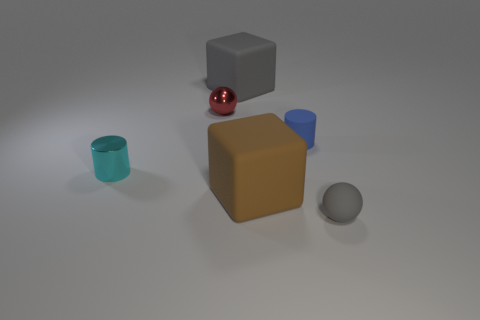How many objects are the same color as the tiny rubber sphere?
Give a very brief answer. 1. There is a tiny ball that is on the left side of the big gray matte object; are there any small metallic things that are on the left side of it?
Provide a short and direct response. Yes. How many other things are there of the same shape as the big gray object?
Your answer should be very brief. 1. There is a gray rubber object that is behind the red shiny ball; is its shape the same as the thing that is on the right side of the small blue object?
Provide a succinct answer. No. There is a small sphere on the left side of the small rubber object in front of the brown block; how many large rubber blocks are to the left of it?
Keep it short and to the point. 0. The tiny shiny sphere has what color?
Your answer should be very brief. Red. How many other objects are there of the same size as the brown block?
Make the answer very short. 1. There is a small gray object that is the same shape as the tiny red metal object; what is its material?
Offer a terse response. Rubber. What material is the tiny sphere that is left of the cube right of the gray thing behind the small gray object?
Ensure brevity in your answer.  Metal. What is the size of the brown block that is made of the same material as the small blue thing?
Your answer should be very brief. Large. 